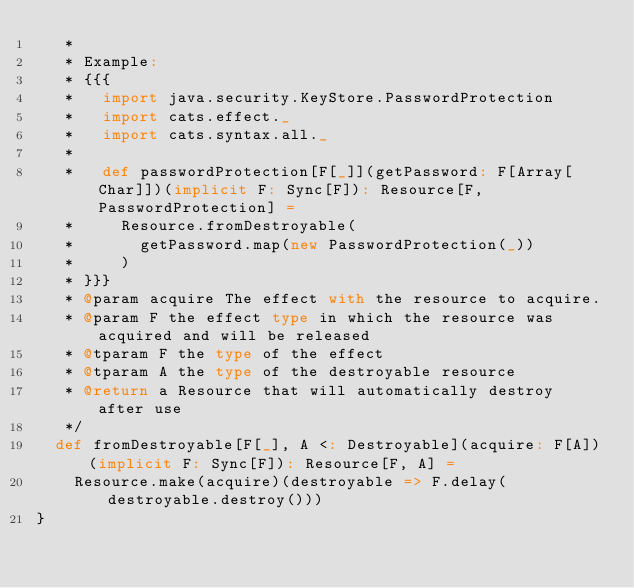Convert code to text. <code><loc_0><loc_0><loc_500><loc_500><_Scala_>   *
   * Example:
   * {{{
   *   import java.security.KeyStore.PasswordProtection
   *   import cats.effect._
   *   import cats.syntax.all._
   *
   *   def passwordProtection[F[_]](getPassword: F[Array[Char]])(implicit F: Sync[F]): Resource[F, PasswordProtection] =
   *     Resource.fromDestroyable(
   *       getPassword.map(new PasswordProtection(_))
   *     )
   * }}}
   * @param acquire The effect with the resource to acquire.
   * @param F the effect type in which the resource was acquired and will be released
   * @tparam F the type of the effect
   * @tparam A the type of the destroyable resource
   * @return a Resource that will automatically destroy after use
   */
  def fromDestroyable[F[_], A <: Destroyable](acquire: F[A])(implicit F: Sync[F]): Resource[F, A] =
    Resource.make(acquire)(destroyable => F.delay(destroyable.destroy()))
}
</code> 